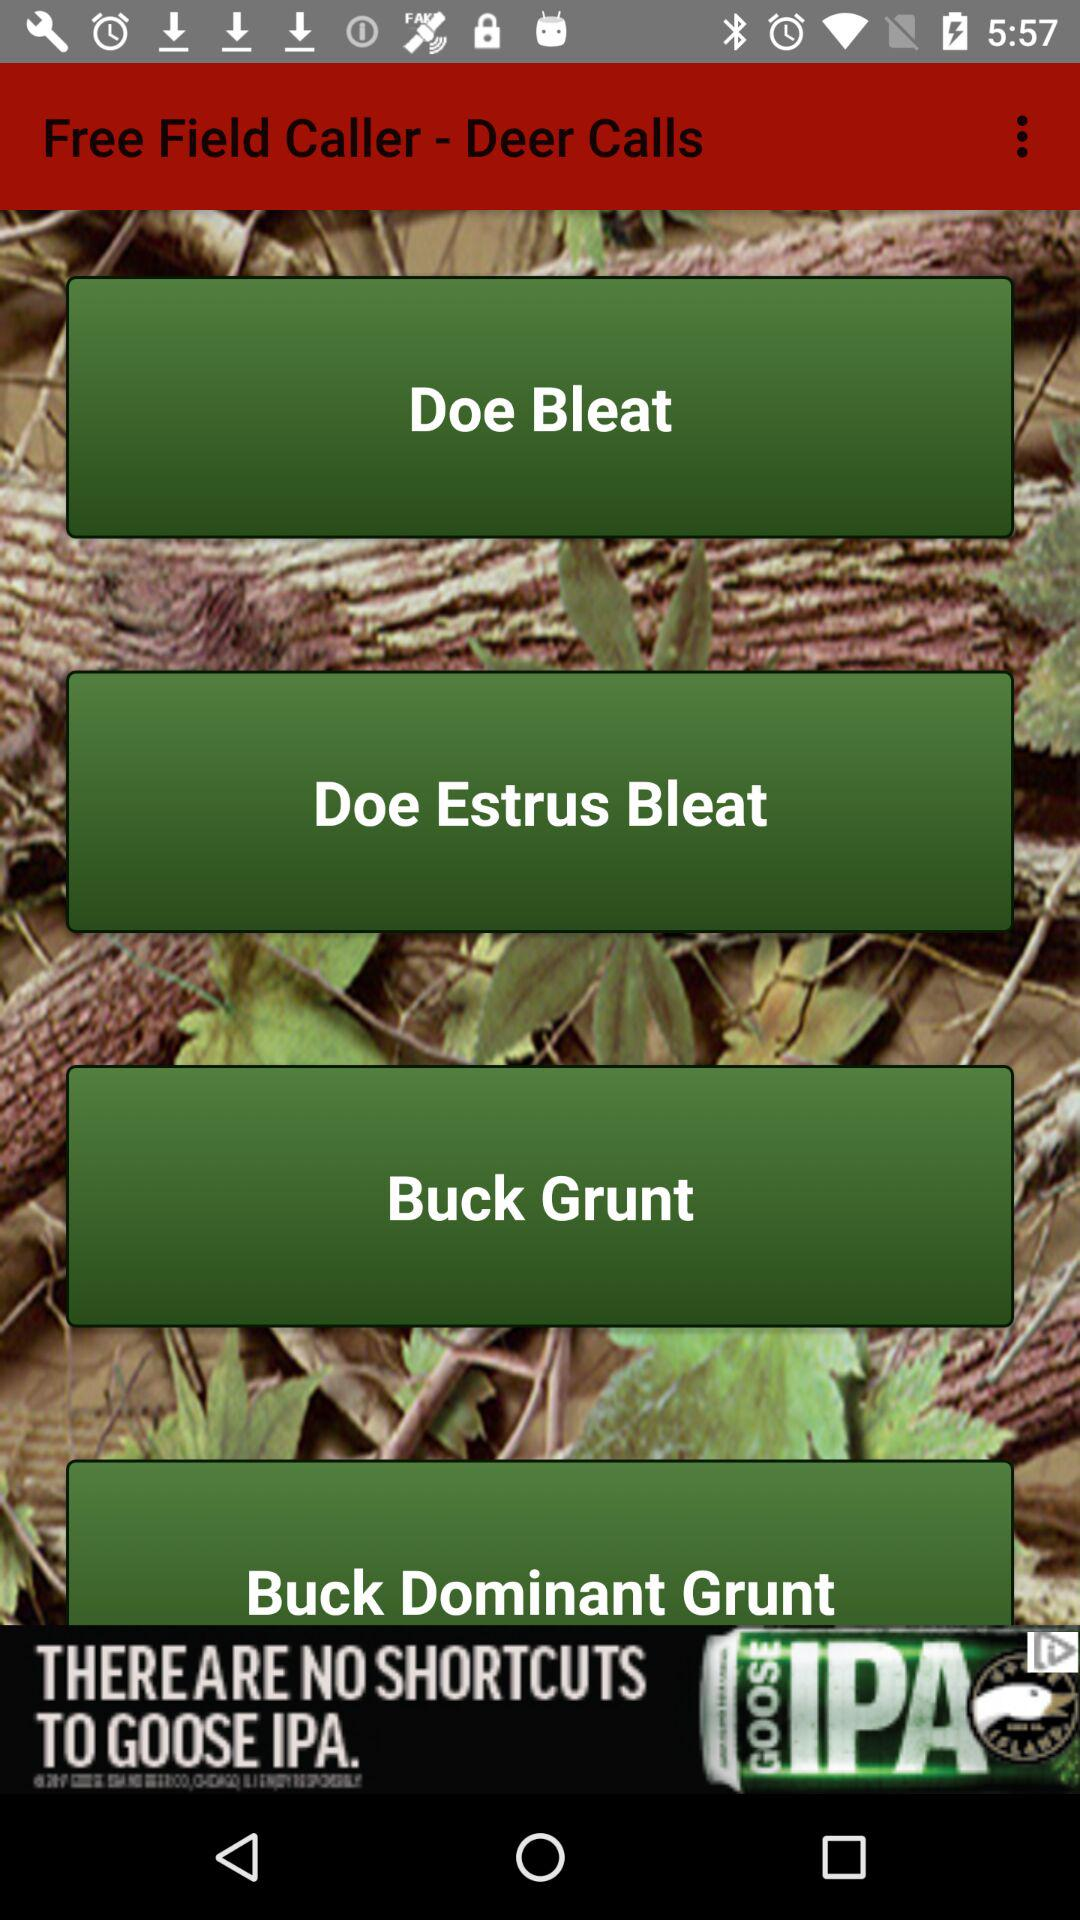What is the name of the application? The name of the application is "Free Field Caller - Deer Calls". 